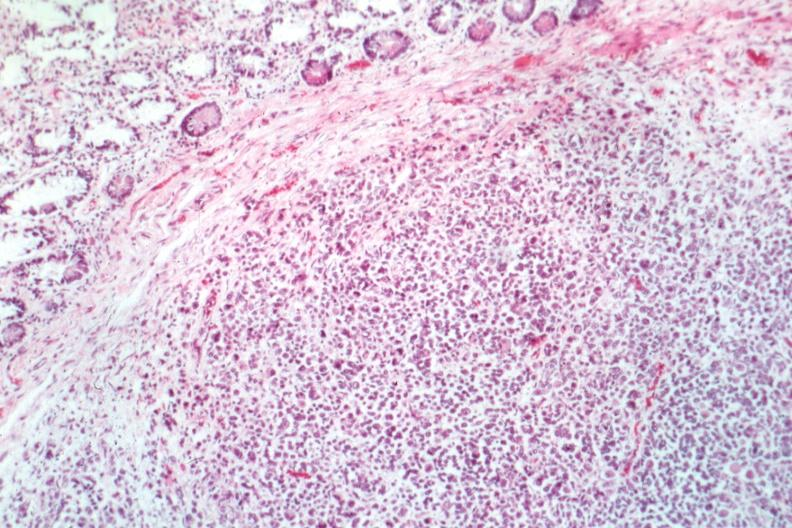what is present?
Answer the question using a single word or phrase. Metastatic malignant melanoma 